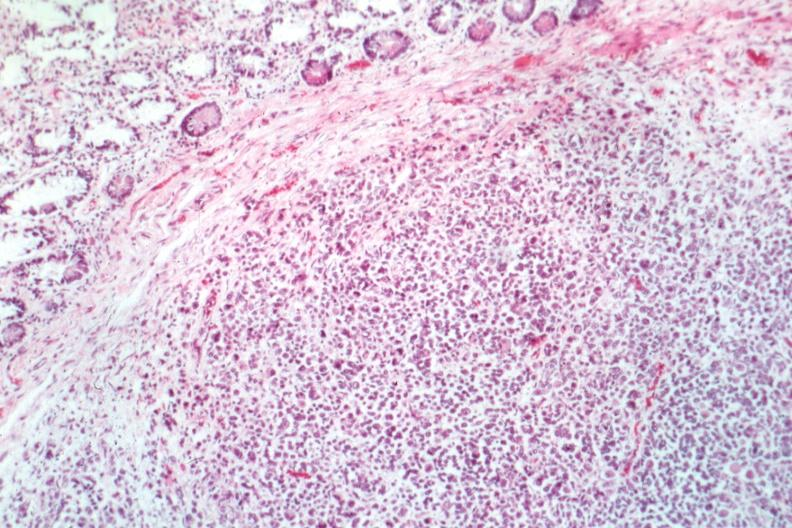what is present?
Answer the question using a single word or phrase. Metastatic malignant melanoma 